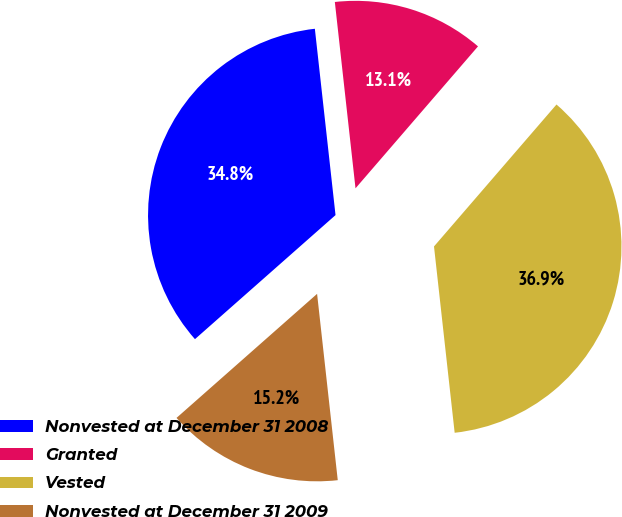Convert chart. <chart><loc_0><loc_0><loc_500><loc_500><pie_chart><fcel>Nonvested at December 31 2008<fcel>Granted<fcel>Vested<fcel>Nonvested at December 31 2009<nl><fcel>34.75%<fcel>13.09%<fcel>36.91%<fcel>15.25%<nl></chart> 